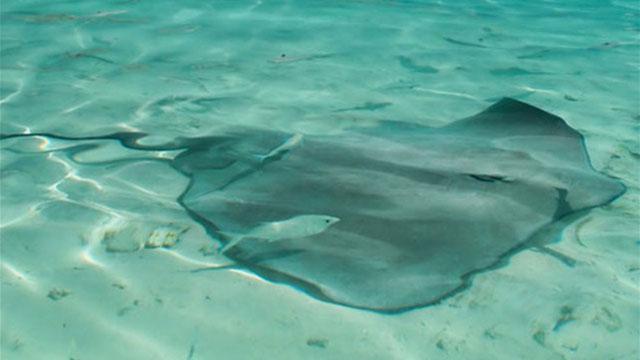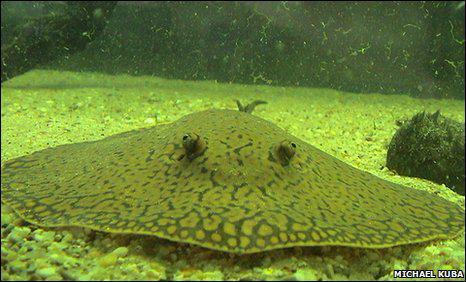The first image is the image on the left, the second image is the image on the right. Examine the images to the left and right. Is the description "An image shows one stingray with spots on its skin." accurate? Answer yes or no. Yes. The first image is the image on the left, the second image is the image on the right. Evaluate the accuracy of this statement regarding the images: "One of the images contains one sting ray with spots.". Is it true? Answer yes or no. Yes. 